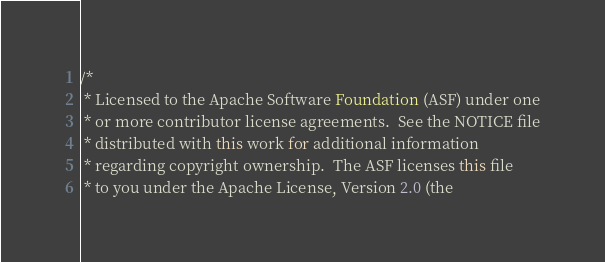<code> <loc_0><loc_0><loc_500><loc_500><_Java_>/*
 * Licensed to the Apache Software Foundation (ASF) under one
 * or more contributor license agreements.  See the NOTICE file
 * distributed with this work for additional information
 * regarding copyright ownership.  The ASF licenses this file
 * to you under the Apache License, Version 2.0 (the</code> 